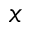<formula> <loc_0><loc_0><loc_500><loc_500>x</formula> 